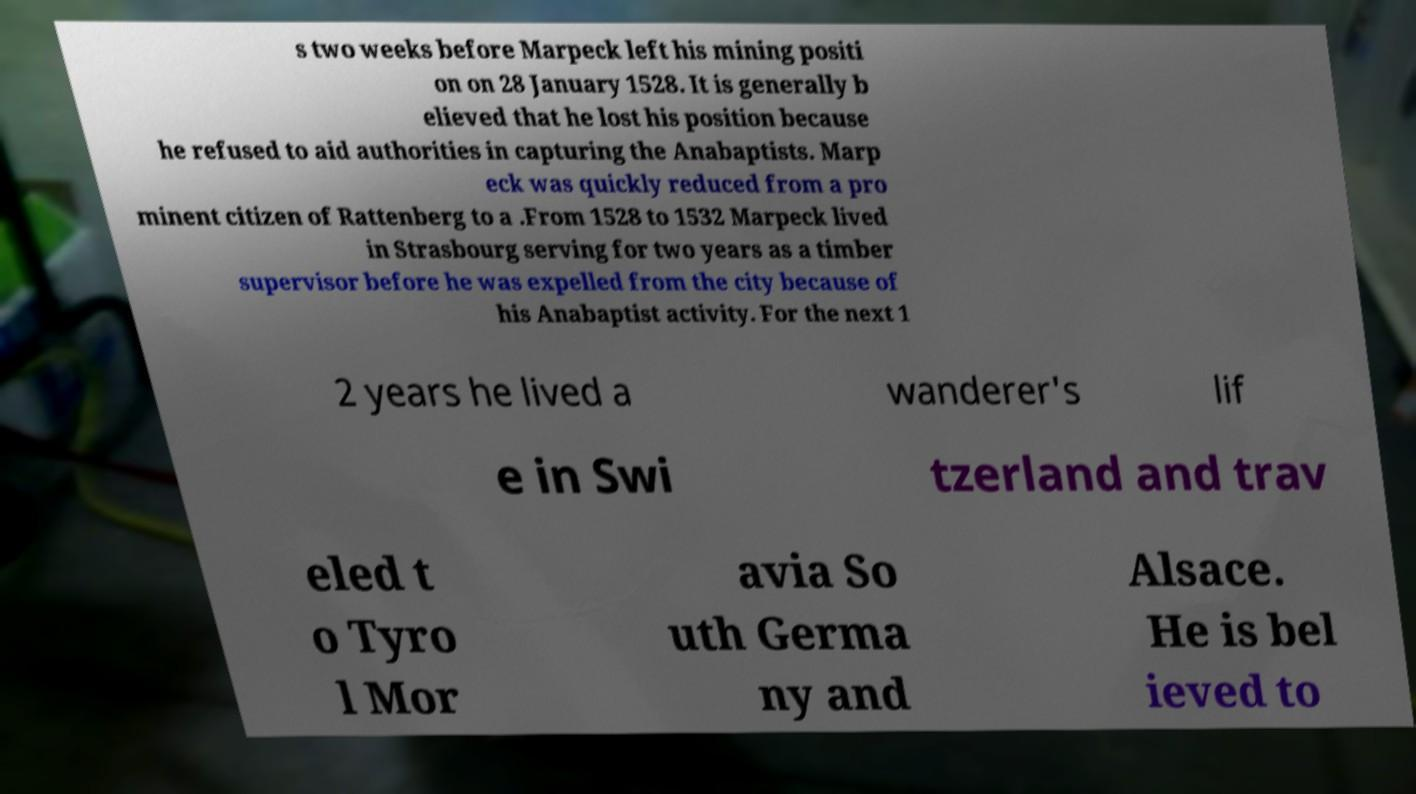Please identify and transcribe the text found in this image. s two weeks before Marpeck left his mining positi on on 28 January 1528. It is generally b elieved that he lost his position because he refused to aid authorities in capturing the Anabaptists. Marp eck was quickly reduced from a pro minent citizen of Rattenberg to a .From 1528 to 1532 Marpeck lived in Strasbourg serving for two years as a timber supervisor before he was expelled from the city because of his Anabaptist activity. For the next 1 2 years he lived a wanderer's lif e in Swi tzerland and trav eled t o Tyro l Mor avia So uth Germa ny and Alsace. He is bel ieved to 